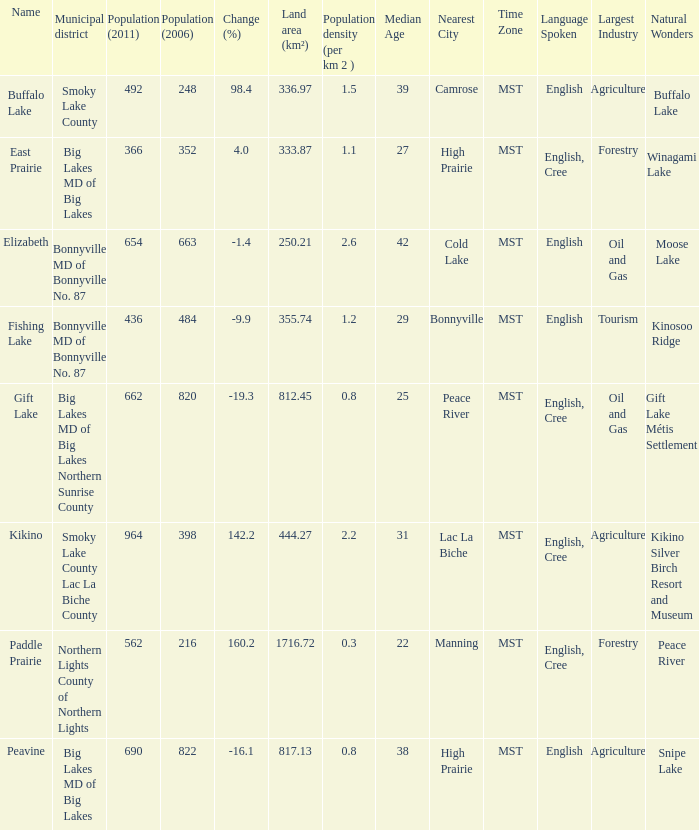What is the population per km2 in Fishing Lake? 1.2. 